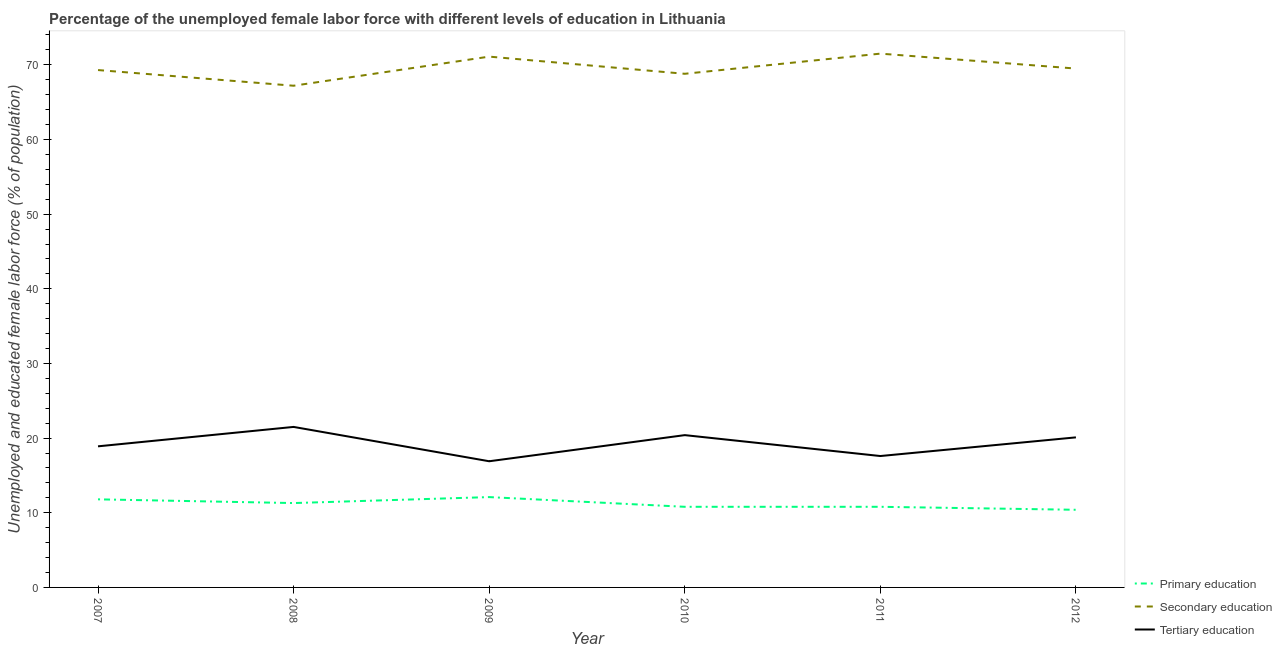Does the line corresponding to percentage of female labor force who received primary education intersect with the line corresponding to percentage of female labor force who received secondary education?
Provide a succinct answer. No. Is the number of lines equal to the number of legend labels?
Provide a succinct answer. Yes. Across all years, what is the maximum percentage of female labor force who received primary education?
Provide a succinct answer. 12.1. Across all years, what is the minimum percentage of female labor force who received primary education?
Provide a succinct answer. 10.4. In which year was the percentage of female labor force who received primary education minimum?
Keep it short and to the point. 2012. What is the total percentage of female labor force who received primary education in the graph?
Offer a terse response. 67.2. What is the difference between the percentage of female labor force who received primary education in 2009 and that in 2011?
Provide a succinct answer. 1.3. What is the difference between the percentage of female labor force who received primary education in 2008 and the percentage of female labor force who received tertiary education in 2010?
Ensure brevity in your answer.  -9.1. What is the average percentage of female labor force who received secondary education per year?
Offer a terse response. 69.57. In the year 2008, what is the difference between the percentage of female labor force who received secondary education and percentage of female labor force who received primary education?
Offer a terse response. 55.9. What is the ratio of the percentage of female labor force who received tertiary education in 2010 to that in 2011?
Give a very brief answer. 1.16. Is the percentage of female labor force who received secondary education in 2007 less than that in 2009?
Your response must be concise. Yes. What is the difference between the highest and the second highest percentage of female labor force who received primary education?
Keep it short and to the point. 0.3. What is the difference between the highest and the lowest percentage of female labor force who received secondary education?
Provide a succinct answer. 4.3. In how many years, is the percentage of female labor force who received secondary education greater than the average percentage of female labor force who received secondary education taken over all years?
Provide a short and direct response. 2. Is the sum of the percentage of female labor force who received tertiary education in 2011 and 2012 greater than the maximum percentage of female labor force who received secondary education across all years?
Ensure brevity in your answer.  No. Is the percentage of female labor force who received primary education strictly less than the percentage of female labor force who received tertiary education over the years?
Provide a short and direct response. Yes. Does the graph contain grids?
Give a very brief answer. No. How are the legend labels stacked?
Keep it short and to the point. Vertical. What is the title of the graph?
Provide a succinct answer. Percentage of the unemployed female labor force with different levels of education in Lithuania. Does "Financial account" appear as one of the legend labels in the graph?
Make the answer very short. No. What is the label or title of the Y-axis?
Your response must be concise. Unemployed and educated female labor force (% of population). What is the Unemployed and educated female labor force (% of population) of Primary education in 2007?
Make the answer very short. 11.8. What is the Unemployed and educated female labor force (% of population) in Secondary education in 2007?
Give a very brief answer. 69.3. What is the Unemployed and educated female labor force (% of population) in Tertiary education in 2007?
Your answer should be very brief. 18.9. What is the Unemployed and educated female labor force (% of population) in Primary education in 2008?
Give a very brief answer. 11.3. What is the Unemployed and educated female labor force (% of population) of Secondary education in 2008?
Provide a succinct answer. 67.2. What is the Unemployed and educated female labor force (% of population) of Primary education in 2009?
Keep it short and to the point. 12.1. What is the Unemployed and educated female labor force (% of population) of Secondary education in 2009?
Provide a short and direct response. 71.1. What is the Unemployed and educated female labor force (% of population) of Tertiary education in 2009?
Make the answer very short. 16.9. What is the Unemployed and educated female labor force (% of population) in Primary education in 2010?
Provide a succinct answer. 10.8. What is the Unemployed and educated female labor force (% of population) of Secondary education in 2010?
Ensure brevity in your answer.  68.8. What is the Unemployed and educated female labor force (% of population) of Tertiary education in 2010?
Your answer should be very brief. 20.4. What is the Unemployed and educated female labor force (% of population) in Primary education in 2011?
Give a very brief answer. 10.8. What is the Unemployed and educated female labor force (% of population) in Secondary education in 2011?
Your answer should be compact. 71.5. What is the Unemployed and educated female labor force (% of population) in Tertiary education in 2011?
Keep it short and to the point. 17.6. What is the Unemployed and educated female labor force (% of population) of Primary education in 2012?
Provide a short and direct response. 10.4. What is the Unemployed and educated female labor force (% of population) of Secondary education in 2012?
Ensure brevity in your answer.  69.5. What is the Unemployed and educated female labor force (% of population) of Tertiary education in 2012?
Give a very brief answer. 20.1. Across all years, what is the maximum Unemployed and educated female labor force (% of population) in Primary education?
Provide a succinct answer. 12.1. Across all years, what is the maximum Unemployed and educated female labor force (% of population) of Secondary education?
Offer a terse response. 71.5. Across all years, what is the maximum Unemployed and educated female labor force (% of population) of Tertiary education?
Offer a terse response. 21.5. Across all years, what is the minimum Unemployed and educated female labor force (% of population) in Primary education?
Keep it short and to the point. 10.4. Across all years, what is the minimum Unemployed and educated female labor force (% of population) of Secondary education?
Your response must be concise. 67.2. Across all years, what is the minimum Unemployed and educated female labor force (% of population) of Tertiary education?
Offer a terse response. 16.9. What is the total Unemployed and educated female labor force (% of population) in Primary education in the graph?
Provide a short and direct response. 67.2. What is the total Unemployed and educated female labor force (% of population) in Secondary education in the graph?
Your answer should be compact. 417.4. What is the total Unemployed and educated female labor force (% of population) of Tertiary education in the graph?
Provide a short and direct response. 115.4. What is the difference between the Unemployed and educated female labor force (% of population) of Primary education in 2007 and that in 2008?
Provide a short and direct response. 0.5. What is the difference between the Unemployed and educated female labor force (% of population) of Tertiary education in 2007 and that in 2008?
Your response must be concise. -2.6. What is the difference between the Unemployed and educated female labor force (% of population) in Primary education in 2007 and that in 2009?
Provide a short and direct response. -0.3. What is the difference between the Unemployed and educated female labor force (% of population) of Primary education in 2007 and that in 2010?
Offer a very short reply. 1. What is the difference between the Unemployed and educated female labor force (% of population) of Secondary education in 2007 and that in 2011?
Provide a short and direct response. -2.2. What is the difference between the Unemployed and educated female labor force (% of population) in Tertiary education in 2007 and that in 2012?
Offer a terse response. -1.2. What is the difference between the Unemployed and educated female labor force (% of population) in Secondary education in 2008 and that in 2009?
Keep it short and to the point. -3.9. What is the difference between the Unemployed and educated female labor force (% of population) of Tertiary education in 2008 and that in 2009?
Provide a succinct answer. 4.6. What is the difference between the Unemployed and educated female labor force (% of population) in Secondary education in 2008 and that in 2010?
Give a very brief answer. -1.6. What is the difference between the Unemployed and educated female labor force (% of population) in Secondary education in 2008 and that in 2011?
Offer a very short reply. -4.3. What is the difference between the Unemployed and educated female labor force (% of population) in Tertiary education in 2008 and that in 2012?
Ensure brevity in your answer.  1.4. What is the difference between the Unemployed and educated female labor force (% of population) of Primary education in 2009 and that in 2010?
Give a very brief answer. 1.3. What is the difference between the Unemployed and educated female labor force (% of population) of Secondary education in 2009 and that in 2010?
Ensure brevity in your answer.  2.3. What is the difference between the Unemployed and educated female labor force (% of population) of Tertiary education in 2009 and that in 2011?
Offer a terse response. -0.7. What is the difference between the Unemployed and educated female labor force (% of population) in Secondary education in 2009 and that in 2012?
Offer a very short reply. 1.6. What is the difference between the Unemployed and educated female labor force (% of population) in Primary education in 2010 and that in 2011?
Keep it short and to the point. 0. What is the difference between the Unemployed and educated female labor force (% of population) of Tertiary education in 2010 and that in 2011?
Give a very brief answer. 2.8. What is the difference between the Unemployed and educated female labor force (% of population) in Secondary education in 2011 and that in 2012?
Offer a very short reply. 2. What is the difference between the Unemployed and educated female labor force (% of population) in Primary education in 2007 and the Unemployed and educated female labor force (% of population) in Secondary education in 2008?
Your answer should be very brief. -55.4. What is the difference between the Unemployed and educated female labor force (% of population) of Secondary education in 2007 and the Unemployed and educated female labor force (% of population) of Tertiary education in 2008?
Make the answer very short. 47.8. What is the difference between the Unemployed and educated female labor force (% of population) of Primary education in 2007 and the Unemployed and educated female labor force (% of population) of Secondary education in 2009?
Ensure brevity in your answer.  -59.3. What is the difference between the Unemployed and educated female labor force (% of population) of Primary education in 2007 and the Unemployed and educated female labor force (% of population) of Tertiary education in 2009?
Your answer should be very brief. -5.1. What is the difference between the Unemployed and educated female labor force (% of population) of Secondary education in 2007 and the Unemployed and educated female labor force (% of population) of Tertiary education in 2009?
Make the answer very short. 52.4. What is the difference between the Unemployed and educated female labor force (% of population) of Primary education in 2007 and the Unemployed and educated female labor force (% of population) of Secondary education in 2010?
Your answer should be compact. -57. What is the difference between the Unemployed and educated female labor force (% of population) of Secondary education in 2007 and the Unemployed and educated female labor force (% of population) of Tertiary education in 2010?
Provide a succinct answer. 48.9. What is the difference between the Unemployed and educated female labor force (% of population) of Primary education in 2007 and the Unemployed and educated female labor force (% of population) of Secondary education in 2011?
Your answer should be very brief. -59.7. What is the difference between the Unemployed and educated female labor force (% of population) in Secondary education in 2007 and the Unemployed and educated female labor force (% of population) in Tertiary education in 2011?
Offer a terse response. 51.7. What is the difference between the Unemployed and educated female labor force (% of population) of Primary education in 2007 and the Unemployed and educated female labor force (% of population) of Secondary education in 2012?
Ensure brevity in your answer.  -57.7. What is the difference between the Unemployed and educated female labor force (% of population) of Secondary education in 2007 and the Unemployed and educated female labor force (% of population) of Tertiary education in 2012?
Ensure brevity in your answer.  49.2. What is the difference between the Unemployed and educated female labor force (% of population) of Primary education in 2008 and the Unemployed and educated female labor force (% of population) of Secondary education in 2009?
Keep it short and to the point. -59.8. What is the difference between the Unemployed and educated female labor force (% of population) of Primary education in 2008 and the Unemployed and educated female labor force (% of population) of Tertiary education in 2009?
Your answer should be compact. -5.6. What is the difference between the Unemployed and educated female labor force (% of population) of Secondary education in 2008 and the Unemployed and educated female labor force (% of population) of Tertiary education in 2009?
Ensure brevity in your answer.  50.3. What is the difference between the Unemployed and educated female labor force (% of population) of Primary education in 2008 and the Unemployed and educated female labor force (% of population) of Secondary education in 2010?
Your response must be concise. -57.5. What is the difference between the Unemployed and educated female labor force (% of population) in Secondary education in 2008 and the Unemployed and educated female labor force (% of population) in Tertiary education in 2010?
Give a very brief answer. 46.8. What is the difference between the Unemployed and educated female labor force (% of population) of Primary education in 2008 and the Unemployed and educated female labor force (% of population) of Secondary education in 2011?
Give a very brief answer. -60.2. What is the difference between the Unemployed and educated female labor force (% of population) in Secondary education in 2008 and the Unemployed and educated female labor force (% of population) in Tertiary education in 2011?
Give a very brief answer. 49.6. What is the difference between the Unemployed and educated female labor force (% of population) in Primary education in 2008 and the Unemployed and educated female labor force (% of population) in Secondary education in 2012?
Offer a terse response. -58.2. What is the difference between the Unemployed and educated female labor force (% of population) of Primary education in 2008 and the Unemployed and educated female labor force (% of population) of Tertiary education in 2012?
Provide a short and direct response. -8.8. What is the difference between the Unemployed and educated female labor force (% of population) in Secondary education in 2008 and the Unemployed and educated female labor force (% of population) in Tertiary education in 2012?
Keep it short and to the point. 47.1. What is the difference between the Unemployed and educated female labor force (% of population) in Primary education in 2009 and the Unemployed and educated female labor force (% of population) in Secondary education in 2010?
Keep it short and to the point. -56.7. What is the difference between the Unemployed and educated female labor force (% of population) of Secondary education in 2009 and the Unemployed and educated female labor force (% of population) of Tertiary education in 2010?
Offer a terse response. 50.7. What is the difference between the Unemployed and educated female labor force (% of population) in Primary education in 2009 and the Unemployed and educated female labor force (% of population) in Secondary education in 2011?
Your answer should be compact. -59.4. What is the difference between the Unemployed and educated female labor force (% of population) in Primary education in 2009 and the Unemployed and educated female labor force (% of population) in Tertiary education in 2011?
Make the answer very short. -5.5. What is the difference between the Unemployed and educated female labor force (% of population) in Secondary education in 2009 and the Unemployed and educated female labor force (% of population) in Tertiary education in 2011?
Keep it short and to the point. 53.5. What is the difference between the Unemployed and educated female labor force (% of population) of Primary education in 2009 and the Unemployed and educated female labor force (% of population) of Secondary education in 2012?
Offer a terse response. -57.4. What is the difference between the Unemployed and educated female labor force (% of population) in Primary education in 2009 and the Unemployed and educated female labor force (% of population) in Tertiary education in 2012?
Provide a succinct answer. -8. What is the difference between the Unemployed and educated female labor force (% of population) of Secondary education in 2009 and the Unemployed and educated female labor force (% of population) of Tertiary education in 2012?
Ensure brevity in your answer.  51. What is the difference between the Unemployed and educated female labor force (% of population) in Primary education in 2010 and the Unemployed and educated female labor force (% of population) in Secondary education in 2011?
Ensure brevity in your answer.  -60.7. What is the difference between the Unemployed and educated female labor force (% of population) of Secondary education in 2010 and the Unemployed and educated female labor force (% of population) of Tertiary education in 2011?
Provide a short and direct response. 51.2. What is the difference between the Unemployed and educated female labor force (% of population) in Primary education in 2010 and the Unemployed and educated female labor force (% of population) in Secondary education in 2012?
Give a very brief answer. -58.7. What is the difference between the Unemployed and educated female labor force (% of population) of Secondary education in 2010 and the Unemployed and educated female labor force (% of population) of Tertiary education in 2012?
Give a very brief answer. 48.7. What is the difference between the Unemployed and educated female labor force (% of population) of Primary education in 2011 and the Unemployed and educated female labor force (% of population) of Secondary education in 2012?
Keep it short and to the point. -58.7. What is the difference between the Unemployed and educated female labor force (% of population) of Secondary education in 2011 and the Unemployed and educated female labor force (% of population) of Tertiary education in 2012?
Your response must be concise. 51.4. What is the average Unemployed and educated female labor force (% of population) of Primary education per year?
Your answer should be very brief. 11.2. What is the average Unemployed and educated female labor force (% of population) in Secondary education per year?
Provide a succinct answer. 69.57. What is the average Unemployed and educated female labor force (% of population) in Tertiary education per year?
Your answer should be very brief. 19.23. In the year 2007, what is the difference between the Unemployed and educated female labor force (% of population) of Primary education and Unemployed and educated female labor force (% of population) of Secondary education?
Provide a short and direct response. -57.5. In the year 2007, what is the difference between the Unemployed and educated female labor force (% of population) in Primary education and Unemployed and educated female labor force (% of population) in Tertiary education?
Your answer should be very brief. -7.1. In the year 2007, what is the difference between the Unemployed and educated female labor force (% of population) of Secondary education and Unemployed and educated female labor force (% of population) of Tertiary education?
Provide a short and direct response. 50.4. In the year 2008, what is the difference between the Unemployed and educated female labor force (% of population) in Primary education and Unemployed and educated female labor force (% of population) in Secondary education?
Your answer should be compact. -55.9. In the year 2008, what is the difference between the Unemployed and educated female labor force (% of population) of Secondary education and Unemployed and educated female labor force (% of population) of Tertiary education?
Keep it short and to the point. 45.7. In the year 2009, what is the difference between the Unemployed and educated female labor force (% of population) of Primary education and Unemployed and educated female labor force (% of population) of Secondary education?
Make the answer very short. -59. In the year 2009, what is the difference between the Unemployed and educated female labor force (% of population) in Primary education and Unemployed and educated female labor force (% of population) in Tertiary education?
Provide a short and direct response. -4.8. In the year 2009, what is the difference between the Unemployed and educated female labor force (% of population) in Secondary education and Unemployed and educated female labor force (% of population) in Tertiary education?
Keep it short and to the point. 54.2. In the year 2010, what is the difference between the Unemployed and educated female labor force (% of population) of Primary education and Unemployed and educated female labor force (% of population) of Secondary education?
Keep it short and to the point. -58. In the year 2010, what is the difference between the Unemployed and educated female labor force (% of population) of Secondary education and Unemployed and educated female labor force (% of population) of Tertiary education?
Give a very brief answer. 48.4. In the year 2011, what is the difference between the Unemployed and educated female labor force (% of population) of Primary education and Unemployed and educated female labor force (% of population) of Secondary education?
Your response must be concise. -60.7. In the year 2011, what is the difference between the Unemployed and educated female labor force (% of population) in Primary education and Unemployed and educated female labor force (% of population) in Tertiary education?
Your response must be concise. -6.8. In the year 2011, what is the difference between the Unemployed and educated female labor force (% of population) in Secondary education and Unemployed and educated female labor force (% of population) in Tertiary education?
Your answer should be very brief. 53.9. In the year 2012, what is the difference between the Unemployed and educated female labor force (% of population) of Primary education and Unemployed and educated female labor force (% of population) of Secondary education?
Your answer should be very brief. -59.1. In the year 2012, what is the difference between the Unemployed and educated female labor force (% of population) in Secondary education and Unemployed and educated female labor force (% of population) in Tertiary education?
Make the answer very short. 49.4. What is the ratio of the Unemployed and educated female labor force (% of population) of Primary education in 2007 to that in 2008?
Ensure brevity in your answer.  1.04. What is the ratio of the Unemployed and educated female labor force (% of population) of Secondary education in 2007 to that in 2008?
Your answer should be compact. 1.03. What is the ratio of the Unemployed and educated female labor force (% of population) in Tertiary education in 2007 to that in 2008?
Offer a terse response. 0.88. What is the ratio of the Unemployed and educated female labor force (% of population) in Primary education in 2007 to that in 2009?
Provide a short and direct response. 0.98. What is the ratio of the Unemployed and educated female labor force (% of population) of Secondary education in 2007 to that in 2009?
Provide a short and direct response. 0.97. What is the ratio of the Unemployed and educated female labor force (% of population) of Tertiary education in 2007 to that in 2009?
Your answer should be compact. 1.12. What is the ratio of the Unemployed and educated female labor force (% of population) of Primary education in 2007 to that in 2010?
Your answer should be very brief. 1.09. What is the ratio of the Unemployed and educated female labor force (% of population) of Secondary education in 2007 to that in 2010?
Offer a terse response. 1.01. What is the ratio of the Unemployed and educated female labor force (% of population) of Tertiary education in 2007 to that in 2010?
Keep it short and to the point. 0.93. What is the ratio of the Unemployed and educated female labor force (% of population) in Primary education in 2007 to that in 2011?
Provide a short and direct response. 1.09. What is the ratio of the Unemployed and educated female labor force (% of population) in Secondary education in 2007 to that in 2011?
Your answer should be very brief. 0.97. What is the ratio of the Unemployed and educated female labor force (% of population) of Tertiary education in 2007 to that in 2011?
Your response must be concise. 1.07. What is the ratio of the Unemployed and educated female labor force (% of population) in Primary education in 2007 to that in 2012?
Your answer should be compact. 1.13. What is the ratio of the Unemployed and educated female labor force (% of population) of Secondary education in 2007 to that in 2012?
Ensure brevity in your answer.  1. What is the ratio of the Unemployed and educated female labor force (% of population) in Tertiary education in 2007 to that in 2012?
Your answer should be very brief. 0.94. What is the ratio of the Unemployed and educated female labor force (% of population) in Primary education in 2008 to that in 2009?
Give a very brief answer. 0.93. What is the ratio of the Unemployed and educated female labor force (% of population) of Secondary education in 2008 to that in 2009?
Keep it short and to the point. 0.95. What is the ratio of the Unemployed and educated female labor force (% of population) of Tertiary education in 2008 to that in 2009?
Offer a very short reply. 1.27. What is the ratio of the Unemployed and educated female labor force (% of population) of Primary education in 2008 to that in 2010?
Offer a terse response. 1.05. What is the ratio of the Unemployed and educated female labor force (% of population) in Secondary education in 2008 to that in 2010?
Give a very brief answer. 0.98. What is the ratio of the Unemployed and educated female labor force (% of population) of Tertiary education in 2008 to that in 2010?
Your answer should be compact. 1.05. What is the ratio of the Unemployed and educated female labor force (% of population) of Primary education in 2008 to that in 2011?
Make the answer very short. 1.05. What is the ratio of the Unemployed and educated female labor force (% of population) in Secondary education in 2008 to that in 2011?
Offer a very short reply. 0.94. What is the ratio of the Unemployed and educated female labor force (% of population) in Tertiary education in 2008 to that in 2011?
Your answer should be compact. 1.22. What is the ratio of the Unemployed and educated female labor force (% of population) in Primary education in 2008 to that in 2012?
Offer a very short reply. 1.09. What is the ratio of the Unemployed and educated female labor force (% of population) of Secondary education in 2008 to that in 2012?
Keep it short and to the point. 0.97. What is the ratio of the Unemployed and educated female labor force (% of population) in Tertiary education in 2008 to that in 2012?
Offer a terse response. 1.07. What is the ratio of the Unemployed and educated female labor force (% of population) of Primary education in 2009 to that in 2010?
Ensure brevity in your answer.  1.12. What is the ratio of the Unemployed and educated female labor force (% of population) in Secondary education in 2009 to that in 2010?
Keep it short and to the point. 1.03. What is the ratio of the Unemployed and educated female labor force (% of population) of Tertiary education in 2009 to that in 2010?
Ensure brevity in your answer.  0.83. What is the ratio of the Unemployed and educated female labor force (% of population) in Primary education in 2009 to that in 2011?
Your response must be concise. 1.12. What is the ratio of the Unemployed and educated female labor force (% of population) in Secondary education in 2009 to that in 2011?
Your answer should be very brief. 0.99. What is the ratio of the Unemployed and educated female labor force (% of population) in Tertiary education in 2009 to that in 2011?
Make the answer very short. 0.96. What is the ratio of the Unemployed and educated female labor force (% of population) of Primary education in 2009 to that in 2012?
Provide a short and direct response. 1.16. What is the ratio of the Unemployed and educated female labor force (% of population) in Tertiary education in 2009 to that in 2012?
Ensure brevity in your answer.  0.84. What is the ratio of the Unemployed and educated female labor force (% of population) in Primary education in 2010 to that in 2011?
Your answer should be compact. 1. What is the ratio of the Unemployed and educated female labor force (% of population) in Secondary education in 2010 to that in 2011?
Provide a succinct answer. 0.96. What is the ratio of the Unemployed and educated female labor force (% of population) in Tertiary education in 2010 to that in 2011?
Your response must be concise. 1.16. What is the ratio of the Unemployed and educated female labor force (% of population) in Primary education in 2010 to that in 2012?
Make the answer very short. 1.04. What is the ratio of the Unemployed and educated female labor force (% of population) in Secondary education in 2010 to that in 2012?
Keep it short and to the point. 0.99. What is the ratio of the Unemployed and educated female labor force (% of population) in Tertiary education in 2010 to that in 2012?
Offer a very short reply. 1.01. What is the ratio of the Unemployed and educated female labor force (% of population) of Primary education in 2011 to that in 2012?
Make the answer very short. 1.04. What is the ratio of the Unemployed and educated female labor force (% of population) of Secondary education in 2011 to that in 2012?
Make the answer very short. 1.03. What is the ratio of the Unemployed and educated female labor force (% of population) of Tertiary education in 2011 to that in 2012?
Provide a short and direct response. 0.88. What is the difference between the highest and the second highest Unemployed and educated female labor force (% of population) of Primary education?
Keep it short and to the point. 0.3. What is the difference between the highest and the lowest Unemployed and educated female labor force (% of population) in Primary education?
Ensure brevity in your answer.  1.7. 